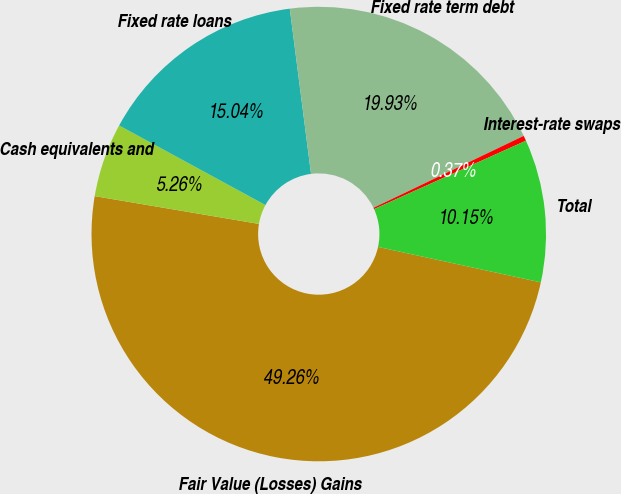<chart> <loc_0><loc_0><loc_500><loc_500><pie_chart><fcel>Fair Value (Losses) Gains<fcel>Cash equivalents and<fcel>Fixed rate loans<fcel>Fixed rate term debt<fcel>Interest-rate swaps<fcel>Total<nl><fcel>49.27%<fcel>5.26%<fcel>15.04%<fcel>19.93%<fcel>0.37%<fcel>10.15%<nl></chart> 